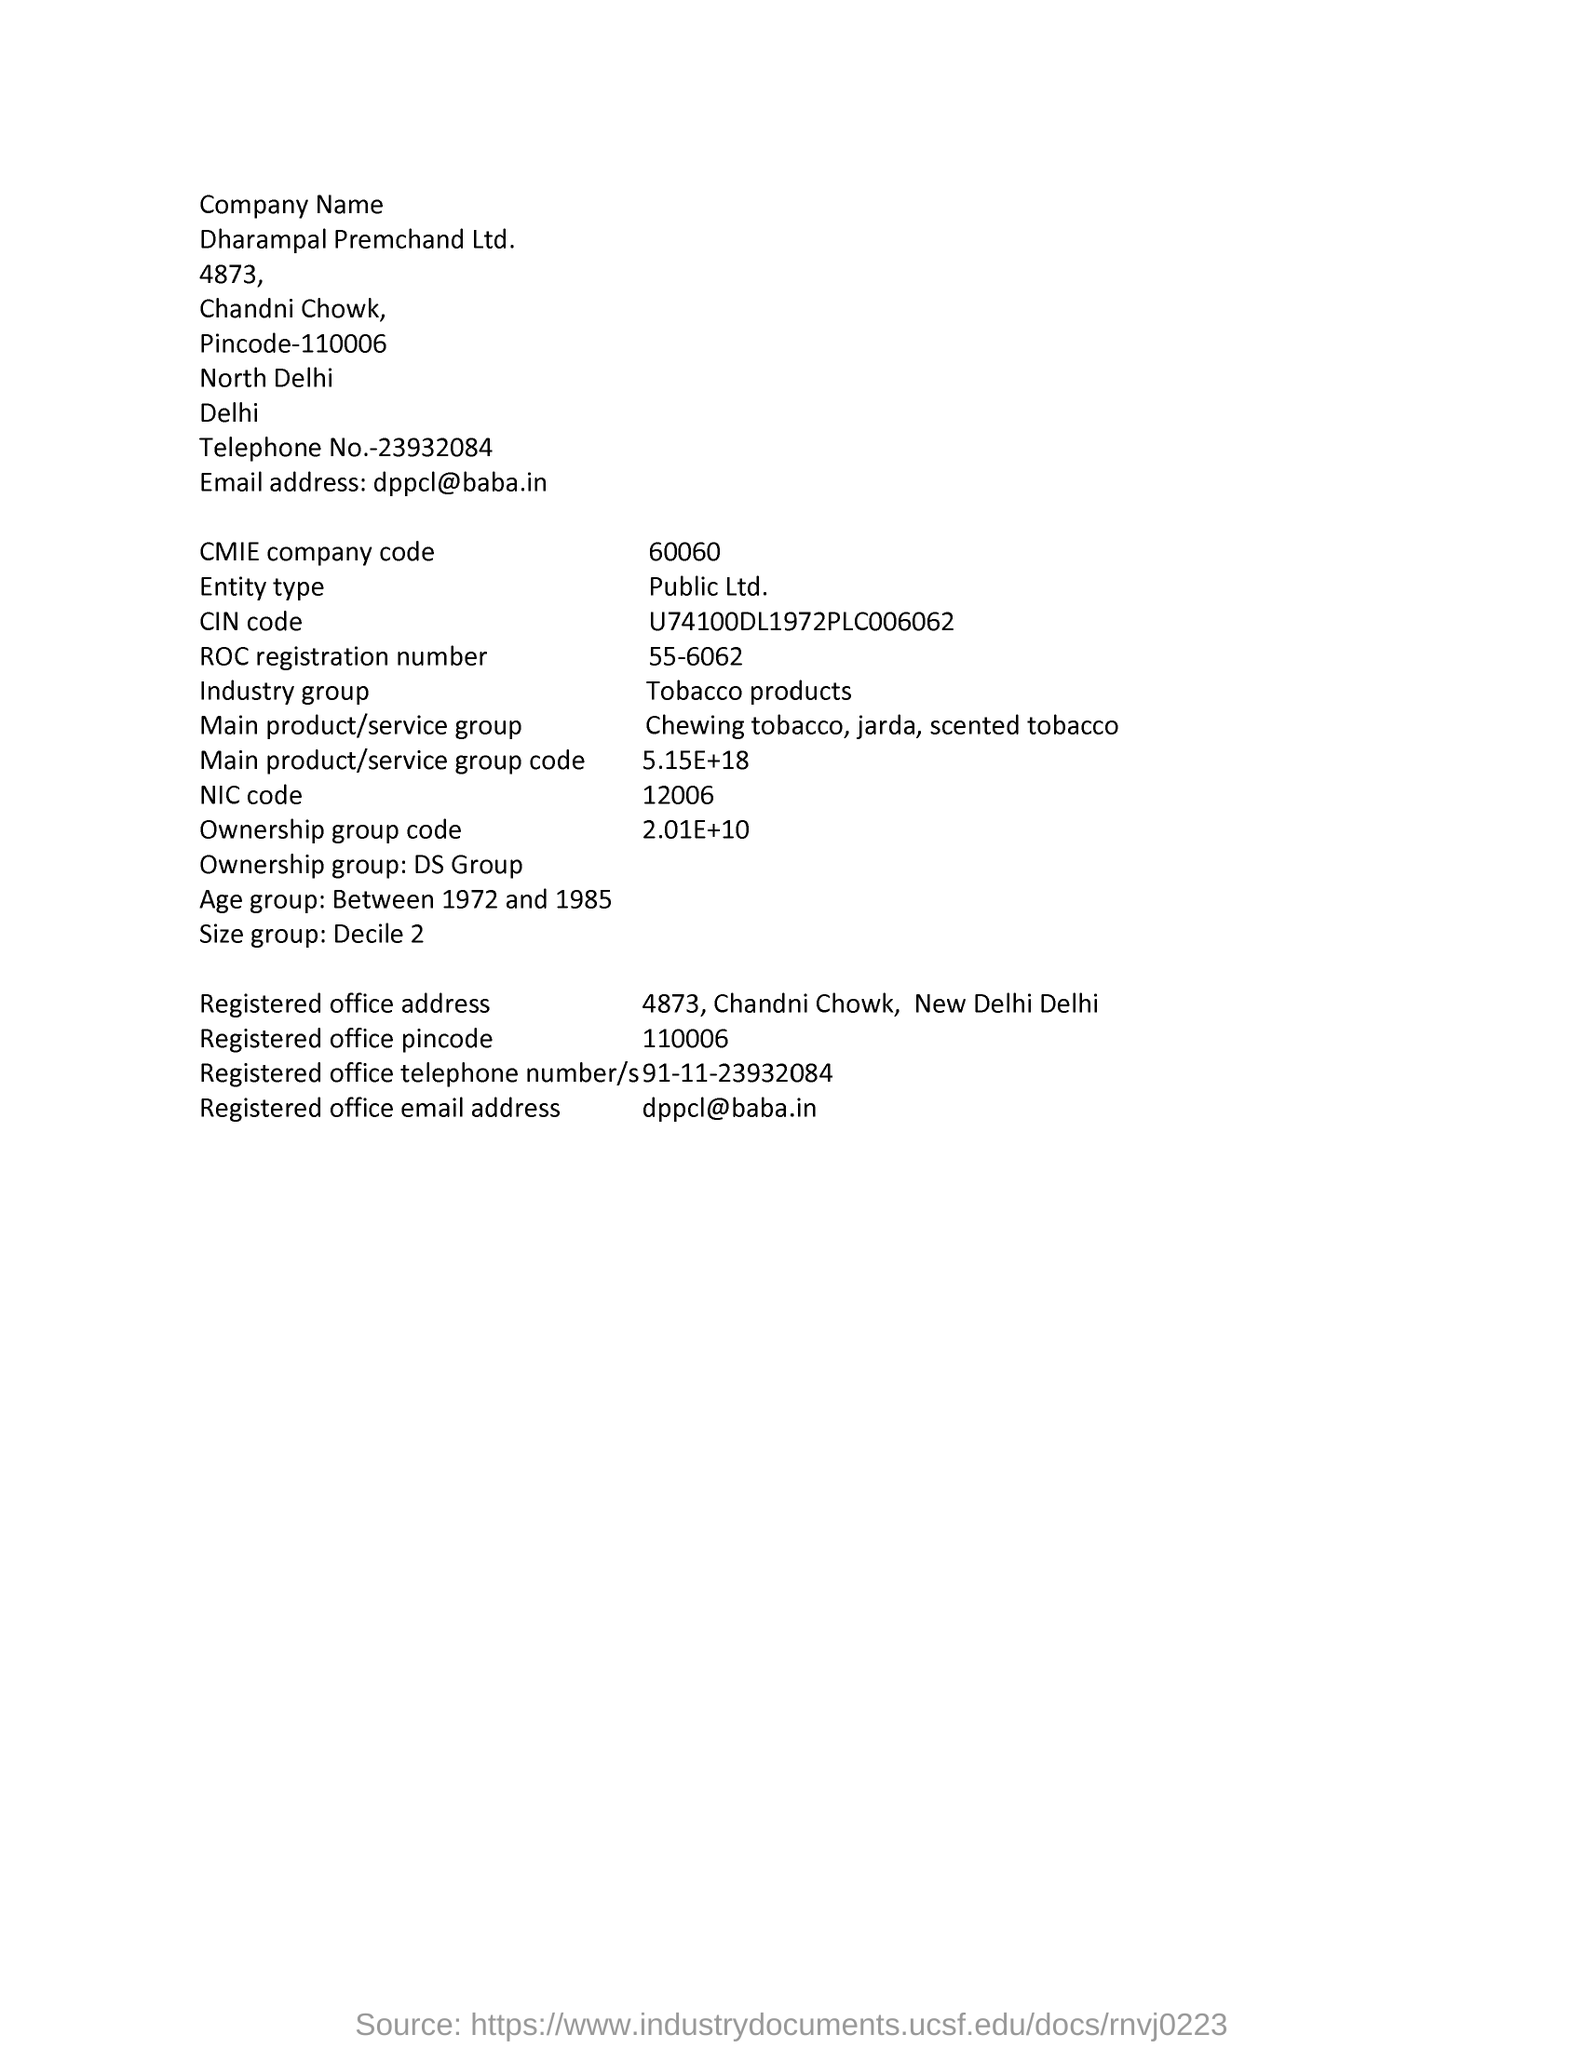List a handful of essential elements in this visual. The term "industry group" refers to a specific category of products, specifically tobacco products. The CMIE code number is 60060. Entity type refers to a public limited company. The NIC code is 12006. 